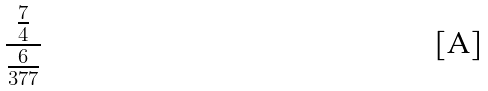<formula> <loc_0><loc_0><loc_500><loc_500>\frac { \frac { 7 } { 4 } } { \frac { 6 } { 3 7 7 } }</formula> 